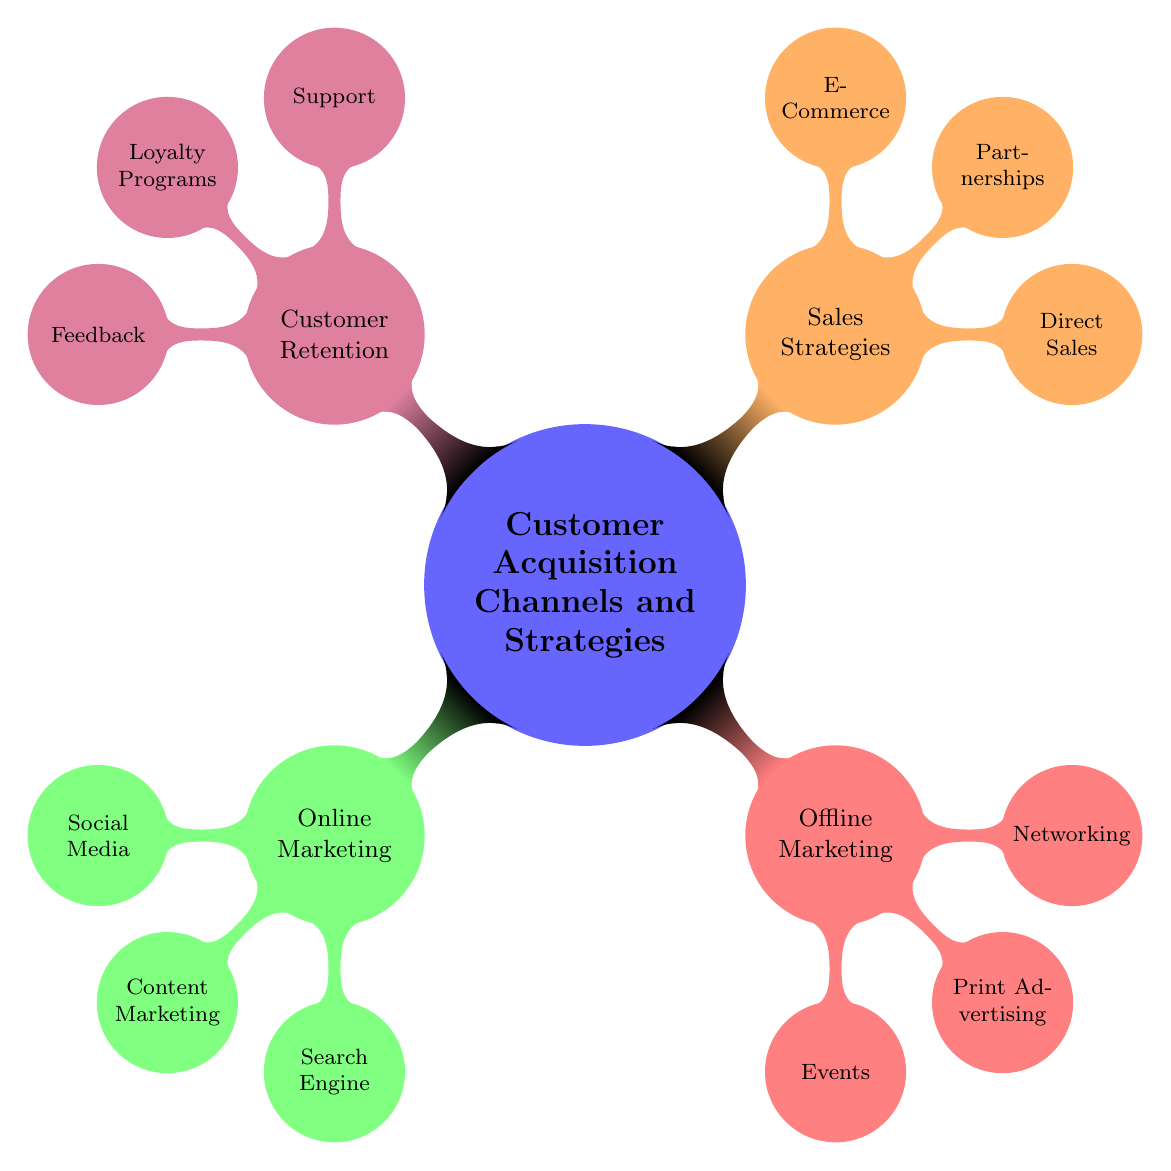What is the main category represented at the center of the diagram? The center node of the mind map is labeled "Customer Acquisition Channels and Strategies," which indicates that it is the primary focus of the diagram.
Answer: Customer Acquisition Channels and Strategies How many main categories are there in the diagram? The diagram features four main categories that branch from the center: Online Marketing, Offline Marketing, Sales Strategies, and Customer Retention. Counting these nodes gives a total of four.
Answer: 4 Which category includes Social Media Advertising? Social Media Advertising falls under the Online Marketing category, which is dedicated to various online promotional strategies. Therefore, it can be identified in that specific branch.
Answer: Online Marketing Name one channel under Offline Marketing. One of the channels listed under Offline Marketing is Events, which encompasses multiple types of events for customer engagement.
Answer: Events What are the three channels listed under Customer Retention? The Customer Retention category has three distinct channels: Support, Loyalty Programs, and Feedback, all aimed at maintaining customer relationships.
Answer: Support, Loyalty Programs, Feedback Which category has the highest sub-node count? In examining the sub-nodes, Online Marketing has three sub-nodes, while the others also have three, but since they are part of the four major categories, it is equal across categories. Therefore, there is no specific category with higher count; they all share equality in node count.
Answer: All equal Name one strategy under Sales Strategies. One strategy highlighted within the Sales Strategies category is Direct Sales, which includes various approaches to selling directly to consumers.
Answer: Direct Sales Which marketing approach is represented by Google Ads? Google Ads is part of the Search Engine Marketing approach within the Online Marketing category, focusing on search engine visibility and performance.
Answer: Search Engine Marketing What type of marketing does Networking belong to? Networking is categorized under Offline Marketing, which encompasses methods of engaging with customers and prospects in a face-to-face manner.
Answer: Offline Marketing 